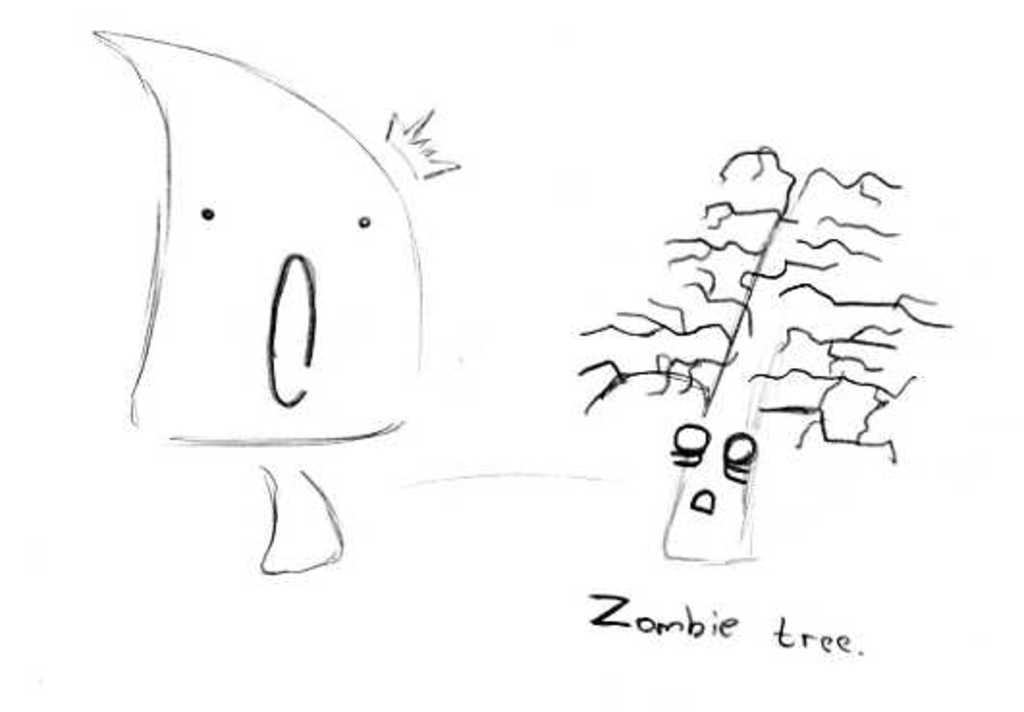Can you describe this image briefly? In this image we can see two drawings. Under this drawing it is written as 'Zombie tree'. Background of the image it is in white color. 